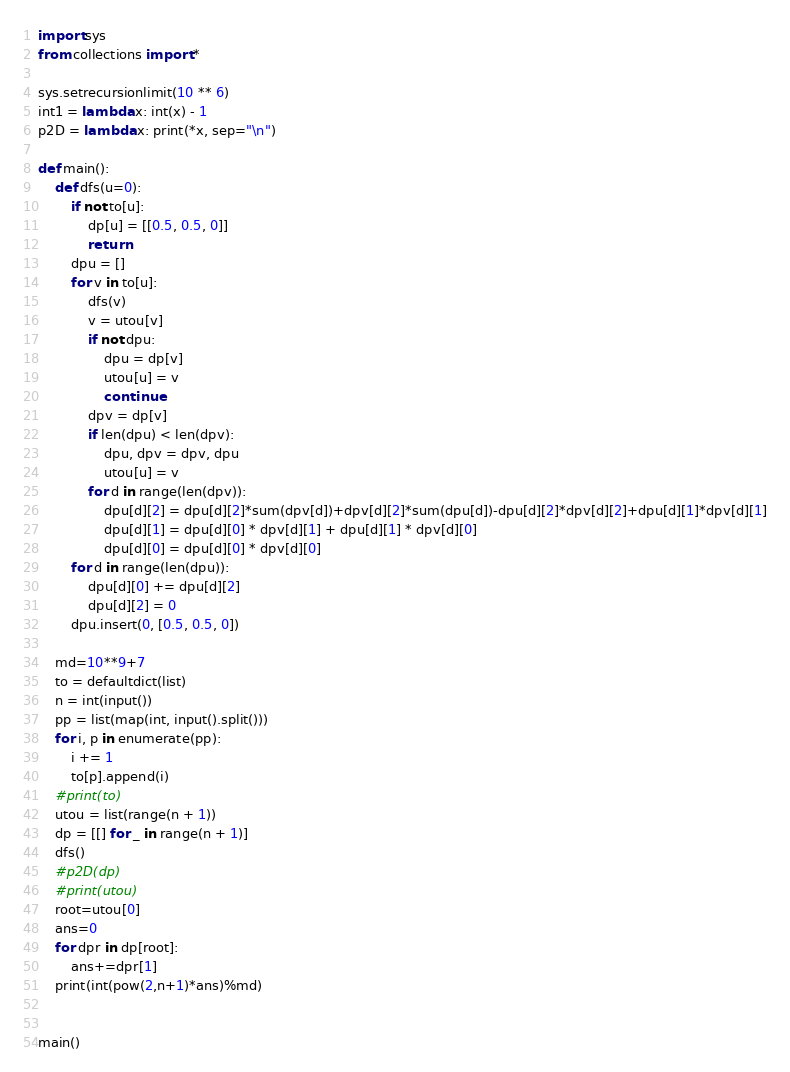<code> <loc_0><loc_0><loc_500><loc_500><_Python_>import sys
from collections import *

sys.setrecursionlimit(10 ** 6)
int1 = lambda x: int(x) - 1
p2D = lambda x: print(*x, sep="\n")

def main():
    def dfs(u=0):
        if not to[u]:
            dp[u] = [[0.5, 0.5, 0]]
            return
        dpu = []
        for v in to[u]:
            dfs(v)
            v = utou[v]
            if not dpu:
                dpu = dp[v]
                utou[u] = v
                continue
            dpv = dp[v]
            if len(dpu) < len(dpv):
                dpu, dpv = dpv, dpu
                utou[u] = v
            for d in range(len(dpv)):
                dpu[d][2] = dpu[d][2]*sum(dpv[d])+dpv[d][2]*sum(dpu[d])-dpu[d][2]*dpv[d][2]+dpu[d][1]*dpv[d][1]
                dpu[d][1] = dpu[d][0] * dpv[d][1] + dpu[d][1] * dpv[d][0]
                dpu[d][0] = dpu[d][0] * dpv[d][0]
        for d in range(len(dpu)):
            dpu[d][0] += dpu[d][2]
            dpu[d][2] = 0
        dpu.insert(0, [0.5, 0.5, 0])

    md=10**9+7
    to = defaultdict(list)
    n = int(input())
    pp = list(map(int, input().split()))
    for i, p in enumerate(pp):
        i += 1
        to[p].append(i)
    #print(to)
    utou = list(range(n + 1))
    dp = [[] for _ in range(n + 1)]
    dfs()
    #p2D(dp)
    #print(utou)
    root=utou[0]
    ans=0
    for dpr in dp[root]:
        ans+=dpr[1]
    print(int(pow(2,n+1)*ans)%md)


main()
</code> 